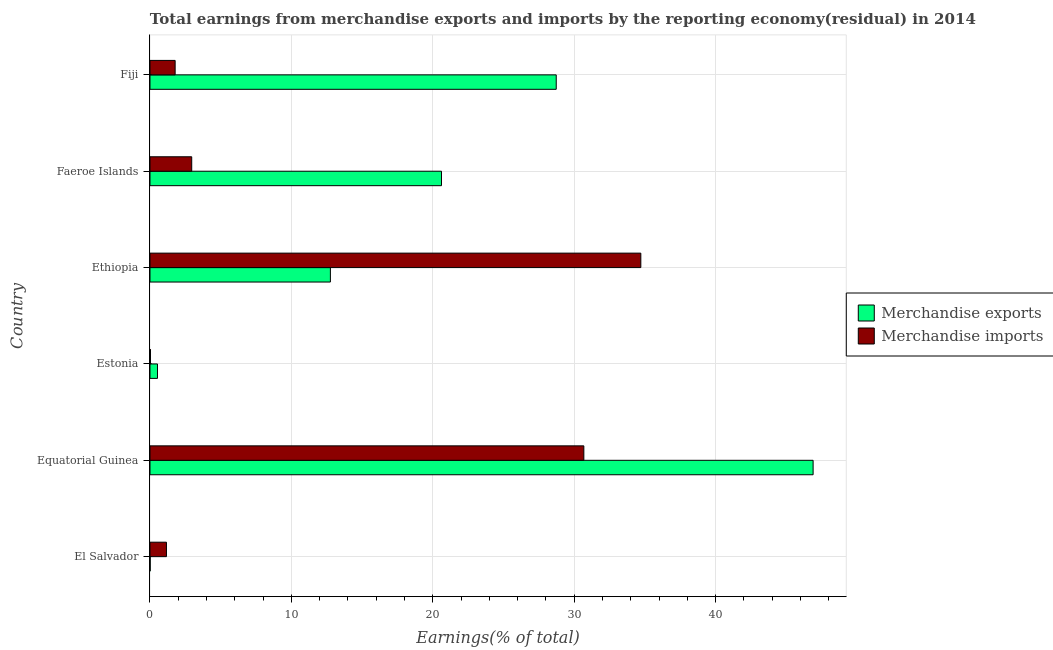How many bars are there on the 1st tick from the top?
Offer a very short reply. 2. How many bars are there on the 6th tick from the bottom?
Ensure brevity in your answer.  2. What is the label of the 3rd group of bars from the top?
Ensure brevity in your answer.  Ethiopia. In how many cases, is the number of bars for a given country not equal to the number of legend labels?
Provide a succinct answer. 0. What is the earnings from merchandise imports in Estonia?
Offer a very short reply. 0.03. Across all countries, what is the maximum earnings from merchandise imports?
Your answer should be very brief. 34.71. Across all countries, what is the minimum earnings from merchandise imports?
Your answer should be very brief. 0.03. In which country was the earnings from merchandise exports maximum?
Your answer should be compact. Equatorial Guinea. In which country was the earnings from merchandise exports minimum?
Offer a terse response. El Salvador. What is the total earnings from merchandise imports in the graph?
Make the answer very short. 71.31. What is the difference between the earnings from merchandise exports in El Salvador and that in Equatorial Guinea?
Provide a short and direct response. -46.88. What is the difference between the earnings from merchandise imports in Equatorial Guinea and the earnings from merchandise exports in Faeroe Islands?
Give a very brief answer. 10.07. What is the average earnings from merchandise imports per country?
Your answer should be very brief. 11.89. What is the difference between the earnings from merchandise imports and earnings from merchandise exports in El Salvador?
Your response must be concise. 1.15. In how many countries, is the earnings from merchandise imports greater than 44 %?
Offer a very short reply. 0. What is the difference between the highest and the second highest earnings from merchandise exports?
Keep it short and to the point. 18.16. What is the difference between the highest and the lowest earnings from merchandise exports?
Your answer should be compact. 46.88. In how many countries, is the earnings from merchandise exports greater than the average earnings from merchandise exports taken over all countries?
Your answer should be very brief. 3. Is the sum of the earnings from merchandise exports in El Salvador and Estonia greater than the maximum earnings from merchandise imports across all countries?
Provide a short and direct response. No. How many countries are there in the graph?
Your answer should be compact. 6. What is the difference between two consecutive major ticks on the X-axis?
Offer a very short reply. 10. Are the values on the major ticks of X-axis written in scientific E-notation?
Ensure brevity in your answer.  No. Does the graph contain grids?
Your response must be concise. Yes. Where does the legend appear in the graph?
Keep it short and to the point. Center right. How many legend labels are there?
Provide a short and direct response. 2. How are the legend labels stacked?
Offer a terse response. Vertical. What is the title of the graph?
Your response must be concise. Total earnings from merchandise exports and imports by the reporting economy(residual) in 2014. Does "By country of asylum" appear as one of the legend labels in the graph?
Ensure brevity in your answer.  No. What is the label or title of the X-axis?
Keep it short and to the point. Earnings(% of total). What is the Earnings(% of total) of Merchandise exports in El Salvador?
Provide a short and direct response. 0.01. What is the Earnings(% of total) of Merchandise imports in El Salvador?
Keep it short and to the point. 1.16. What is the Earnings(% of total) of Merchandise exports in Equatorial Guinea?
Offer a very short reply. 46.89. What is the Earnings(% of total) in Merchandise imports in Equatorial Guinea?
Keep it short and to the point. 30.68. What is the Earnings(% of total) in Merchandise exports in Estonia?
Keep it short and to the point. 0.53. What is the Earnings(% of total) of Merchandise imports in Estonia?
Keep it short and to the point. 0.03. What is the Earnings(% of total) of Merchandise exports in Ethiopia?
Give a very brief answer. 12.76. What is the Earnings(% of total) in Merchandise imports in Ethiopia?
Your answer should be very brief. 34.71. What is the Earnings(% of total) in Merchandise exports in Faeroe Islands?
Give a very brief answer. 20.61. What is the Earnings(% of total) of Merchandise imports in Faeroe Islands?
Offer a very short reply. 2.95. What is the Earnings(% of total) in Merchandise exports in Fiji?
Ensure brevity in your answer.  28.73. What is the Earnings(% of total) in Merchandise imports in Fiji?
Offer a terse response. 1.78. Across all countries, what is the maximum Earnings(% of total) of Merchandise exports?
Provide a short and direct response. 46.89. Across all countries, what is the maximum Earnings(% of total) in Merchandise imports?
Provide a short and direct response. 34.71. Across all countries, what is the minimum Earnings(% of total) of Merchandise exports?
Offer a very short reply. 0.01. Across all countries, what is the minimum Earnings(% of total) of Merchandise imports?
Give a very brief answer. 0.03. What is the total Earnings(% of total) in Merchandise exports in the graph?
Provide a short and direct response. 109.53. What is the total Earnings(% of total) of Merchandise imports in the graph?
Offer a very short reply. 71.31. What is the difference between the Earnings(% of total) of Merchandise exports in El Salvador and that in Equatorial Guinea?
Offer a very short reply. -46.88. What is the difference between the Earnings(% of total) in Merchandise imports in El Salvador and that in Equatorial Guinea?
Provide a short and direct response. -29.51. What is the difference between the Earnings(% of total) of Merchandise exports in El Salvador and that in Estonia?
Your answer should be compact. -0.52. What is the difference between the Earnings(% of total) of Merchandise imports in El Salvador and that in Estonia?
Your response must be concise. 1.13. What is the difference between the Earnings(% of total) of Merchandise exports in El Salvador and that in Ethiopia?
Offer a very short reply. -12.74. What is the difference between the Earnings(% of total) in Merchandise imports in El Salvador and that in Ethiopia?
Provide a succinct answer. -33.54. What is the difference between the Earnings(% of total) of Merchandise exports in El Salvador and that in Faeroe Islands?
Provide a short and direct response. -20.6. What is the difference between the Earnings(% of total) in Merchandise imports in El Salvador and that in Faeroe Islands?
Ensure brevity in your answer.  -1.79. What is the difference between the Earnings(% of total) of Merchandise exports in El Salvador and that in Fiji?
Keep it short and to the point. -28.71. What is the difference between the Earnings(% of total) of Merchandise imports in El Salvador and that in Fiji?
Offer a very short reply. -0.61. What is the difference between the Earnings(% of total) in Merchandise exports in Equatorial Guinea and that in Estonia?
Your answer should be compact. 46.36. What is the difference between the Earnings(% of total) of Merchandise imports in Equatorial Guinea and that in Estonia?
Your answer should be very brief. 30.64. What is the difference between the Earnings(% of total) of Merchandise exports in Equatorial Guinea and that in Ethiopia?
Give a very brief answer. 34.13. What is the difference between the Earnings(% of total) in Merchandise imports in Equatorial Guinea and that in Ethiopia?
Offer a very short reply. -4.03. What is the difference between the Earnings(% of total) of Merchandise exports in Equatorial Guinea and that in Faeroe Islands?
Make the answer very short. 26.28. What is the difference between the Earnings(% of total) of Merchandise imports in Equatorial Guinea and that in Faeroe Islands?
Offer a very short reply. 27.73. What is the difference between the Earnings(% of total) in Merchandise exports in Equatorial Guinea and that in Fiji?
Keep it short and to the point. 18.16. What is the difference between the Earnings(% of total) in Merchandise imports in Equatorial Guinea and that in Fiji?
Offer a terse response. 28.9. What is the difference between the Earnings(% of total) of Merchandise exports in Estonia and that in Ethiopia?
Your answer should be compact. -12.23. What is the difference between the Earnings(% of total) of Merchandise imports in Estonia and that in Ethiopia?
Offer a terse response. -34.67. What is the difference between the Earnings(% of total) of Merchandise exports in Estonia and that in Faeroe Islands?
Keep it short and to the point. -20.08. What is the difference between the Earnings(% of total) of Merchandise imports in Estonia and that in Faeroe Islands?
Make the answer very short. -2.92. What is the difference between the Earnings(% of total) of Merchandise exports in Estonia and that in Fiji?
Provide a short and direct response. -28.2. What is the difference between the Earnings(% of total) of Merchandise imports in Estonia and that in Fiji?
Make the answer very short. -1.74. What is the difference between the Earnings(% of total) of Merchandise exports in Ethiopia and that in Faeroe Islands?
Ensure brevity in your answer.  -7.86. What is the difference between the Earnings(% of total) in Merchandise imports in Ethiopia and that in Faeroe Islands?
Give a very brief answer. 31.76. What is the difference between the Earnings(% of total) of Merchandise exports in Ethiopia and that in Fiji?
Your answer should be compact. -15.97. What is the difference between the Earnings(% of total) in Merchandise imports in Ethiopia and that in Fiji?
Offer a terse response. 32.93. What is the difference between the Earnings(% of total) in Merchandise exports in Faeroe Islands and that in Fiji?
Provide a succinct answer. -8.11. What is the difference between the Earnings(% of total) of Merchandise imports in Faeroe Islands and that in Fiji?
Offer a very short reply. 1.17. What is the difference between the Earnings(% of total) in Merchandise exports in El Salvador and the Earnings(% of total) in Merchandise imports in Equatorial Guinea?
Provide a short and direct response. -30.67. What is the difference between the Earnings(% of total) in Merchandise exports in El Salvador and the Earnings(% of total) in Merchandise imports in Estonia?
Offer a very short reply. -0.02. What is the difference between the Earnings(% of total) in Merchandise exports in El Salvador and the Earnings(% of total) in Merchandise imports in Ethiopia?
Ensure brevity in your answer.  -34.7. What is the difference between the Earnings(% of total) of Merchandise exports in El Salvador and the Earnings(% of total) of Merchandise imports in Faeroe Islands?
Provide a short and direct response. -2.94. What is the difference between the Earnings(% of total) in Merchandise exports in El Salvador and the Earnings(% of total) in Merchandise imports in Fiji?
Offer a terse response. -1.77. What is the difference between the Earnings(% of total) of Merchandise exports in Equatorial Guinea and the Earnings(% of total) of Merchandise imports in Estonia?
Give a very brief answer. 46.86. What is the difference between the Earnings(% of total) of Merchandise exports in Equatorial Guinea and the Earnings(% of total) of Merchandise imports in Ethiopia?
Provide a succinct answer. 12.18. What is the difference between the Earnings(% of total) of Merchandise exports in Equatorial Guinea and the Earnings(% of total) of Merchandise imports in Faeroe Islands?
Offer a very short reply. 43.94. What is the difference between the Earnings(% of total) in Merchandise exports in Equatorial Guinea and the Earnings(% of total) in Merchandise imports in Fiji?
Make the answer very short. 45.11. What is the difference between the Earnings(% of total) of Merchandise exports in Estonia and the Earnings(% of total) of Merchandise imports in Ethiopia?
Offer a very short reply. -34.18. What is the difference between the Earnings(% of total) in Merchandise exports in Estonia and the Earnings(% of total) in Merchandise imports in Faeroe Islands?
Your answer should be very brief. -2.42. What is the difference between the Earnings(% of total) of Merchandise exports in Estonia and the Earnings(% of total) of Merchandise imports in Fiji?
Your response must be concise. -1.25. What is the difference between the Earnings(% of total) in Merchandise exports in Ethiopia and the Earnings(% of total) in Merchandise imports in Faeroe Islands?
Provide a short and direct response. 9.81. What is the difference between the Earnings(% of total) in Merchandise exports in Ethiopia and the Earnings(% of total) in Merchandise imports in Fiji?
Make the answer very short. 10.98. What is the difference between the Earnings(% of total) of Merchandise exports in Faeroe Islands and the Earnings(% of total) of Merchandise imports in Fiji?
Offer a very short reply. 18.83. What is the average Earnings(% of total) in Merchandise exports per country?
Keep it short and to the point. 18.25. What is the average Earnings(% of total) of Merchandise imports per country?
Offer a terse response. 11.89. What is the difference between the Earnings(% of total) in Merchandise exports and Earnings(% of total) in Merchandise imports in El Salvador?
Keep it short and to the point. -1.15. What is the difference between the Earnings(% of total) in Merchandise exports and Earnings(% of total) in Merchandise imports in Equatorial Guinea?
Make the answer very short. 16.21. What is the difference between the Earnings(% of total) in Merchandise exports and Earnings(% of total) in Merchandise imports in Estonia?
Make the answer very short. 0.5. What is the difference between the Earnings(% of total) of Merchandise exports and Earnings(% of total) of Merchandise imports in Ethiopia?
Keep it short and to the point. -21.95. What is the difference between the Earnings(% of total) of Merchandise exports and Earnings(% of total) of Merchandise imports in Faeroe Islands?
Ensure brevity in your answer.  17.66. What is the difference between the Earnings(% of total) in Merchandise exports and Earnings(% of total) in Merchandise imports in Fiji?
Your answer should be compact. 26.95. What is the ratio of the Earnings(% of total) of Merchandise imports in El Salvador to that in Equatorial Guinea?
Ensure brevity in your answer.  0.04. What is the ratio of the Earnings(% of total) in Merchandise exports in El Salvador to that in Estonia?
Offer a very short reply. 0.02. What is the ratio of the Earnings(% of total) in Merchandise imports in El Salvador to that in Estonia?
Your response must be concise. 33.63. What is the ratio of the Earnings(% of total) of Merchandise imports in El Salvador to that in Ethiopia?
Provide a short and direct response. 0.03. What is the ratio of the Earnings(% of total) in Merchandise exports in El Salvador to that in Faeroe Islands?
Provide a short and direct response. 0. What is the ratio of the Earnings(% of total) in Merchandise imports in El Salvador to that in Faeroe Islands?
Your response must be concise. 0.39. What is the ratio of the Earnings(% of total) of Merchandise exports in El Salvador to that in Fiji?
Your answer should be very brief. 0. What is the ratio of the Earnings(% of total) of Merchandise imports in El Salvador to that in Fiji?
Your answer should be very brief. 0.65. What is the ratio of the Earnings(% of total) in Merchandise exports in Equatorial Guinea to that in Estonia?
Make the answer very short. 88.5. What is the ratio of the Earnings(% of total) of Merchandise imports in Equatorial Guinea to that in Estonia?
Make the answer very short. 886.18. What is the ratio of the Earnings(% of total) of Merchandise exports in Equatorial Guinea to that in Ethiopia?
Make the answer very short. 3.68. What is the ratio of the Earnings(% of total) in Merchandise imports in Equatorial Guinea to that in Ethiopia?
Give a very brief answer. 0.88. What is the ratio of the Earnings(% of total) of Merchandise exports in Equatorial Guinea to that in Faeroe Islands?
Make the answer very short. 2.27. What is the ratio of the Earnings(% of total) in Merchandise imports in Equatorial Guinea to that in Faeroe Islands?
Offer a terse response. 10.4. What is the ratio of the Earnings(% of total) in Merchandise exports in Equatorial Guinea to that in Fiji?
Your response must be concise. 1.63. What is the ratio of the Earnings(% of total) in Merchandise imports in Equatorial Guinea to that in Fiji?
Your response must be concise. 17.25. What is the ratio of the Earnings(% of total) of Merchandise exports in Estonia to that in Ethiopia?
Ensure brevity in your answer.  0.04. What is the ratio of the Earnings(% of total) in Merchandise exports in Estonia to that in Faeroe Islands?
Provide a succinct answer. 0.03. What is the ratio of the Earnings(% of total) in Merchandise imports in Estonia to that in Faeroe Islands?
Your answer should be compact. 0.01. What is the ratio of the Earnings(% of total) in Merchandise exports in Estonia to that in Fiji?
Offer a terse response. 0.02. What is the ratio of the Earnings(% of total) of Merchandise imports in Estonia to that in Fiji?
Give a very brief answer. 0.02. What is the ratio of the Earnings(% of total) of Merchandise exports in Ethiopia to that in Faeroe Islands?
Provide a short and direct response. 0.62. What is the ratio of the Earnings(% of total) in Merchandise imports in Ethiopia to that in Faeroe Islands?
Your response must be concise. 11.76. What is the ratio of the Earnings(% of total) of Merchandise exports in Ethiopia to that in Fiji?
Offer a very short reply. 0.44. What is the ratio of the Earnings(% of total) in Merchandise imports in Ethiopia to that in Fiji?
Your answer should be compact. 19.52. What is the ratio of the Earnings(% of total) of Merchandise exports in Faeroe Islands to that in Fiji?
Your answer should be very brief. 0.72. What is the ratio of the Earnings(% of total) in Merchandise imports in Faeroe Islands to that in Fiji?
Your answer should be very brief. 1.66. What is the difference between the highest and the second highest Earnings(% of total) of Merchandise exports?
Make the answer very short. 18.16. What is the difference between the highest and the second highest Earnings(% of total) in Merchandise imports?
Make the answer very short. 4.03. What is the difference between the highest and the lowest Earnings(% of total) of Merchandise exports?
Offer a very short reply. 46.88. What is the difference between the highest and the lowest Earnings(% of total) of Merchandise imports?
Provide a succinct answer. 34.67. 